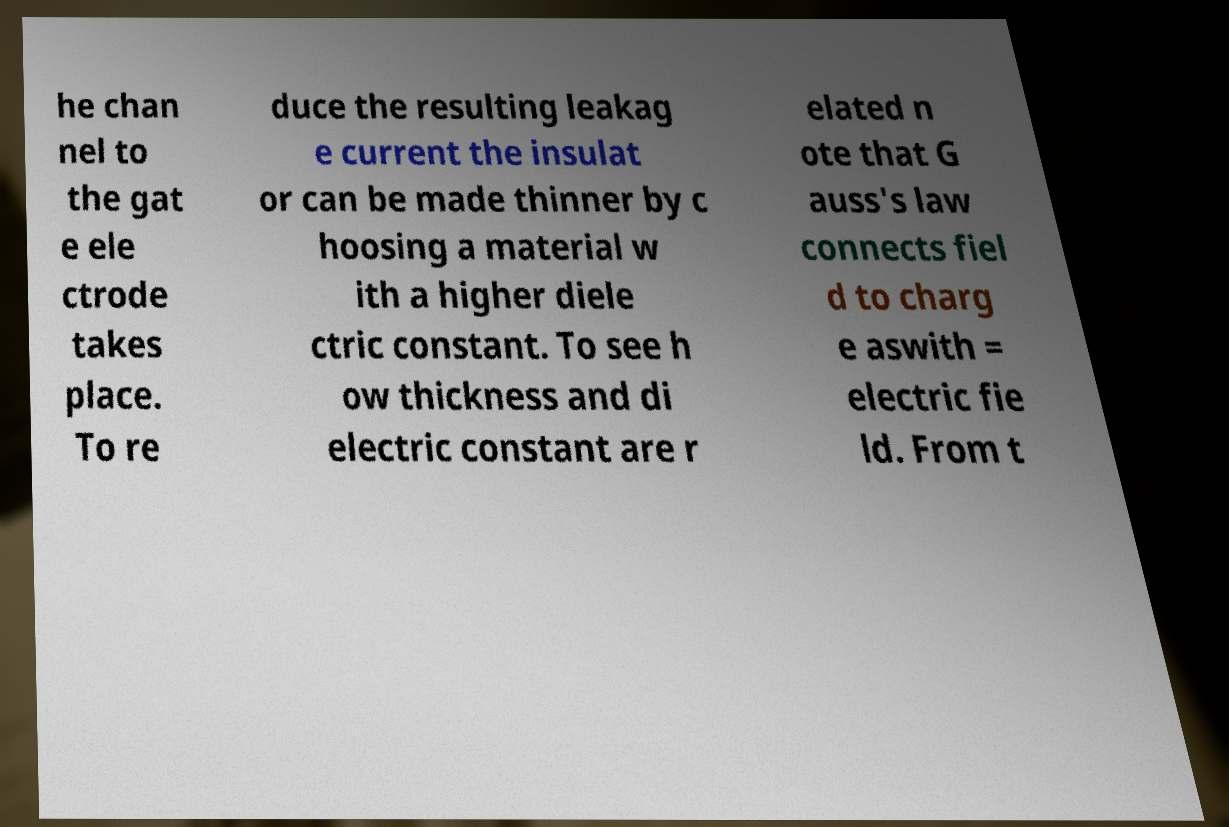Please identify and transcribe the text found in this image. he chan nel to the gat e ele ctrode takes place. To re duce the resulting leakag e current the insulat or can be made thinner by c hoosing a material w ith a higher diele ctric constant. To see h ow thickness and di electric constant are r elated n ote that G auss's law connects fiel d to charg e aswith = electric fie ld. From t 